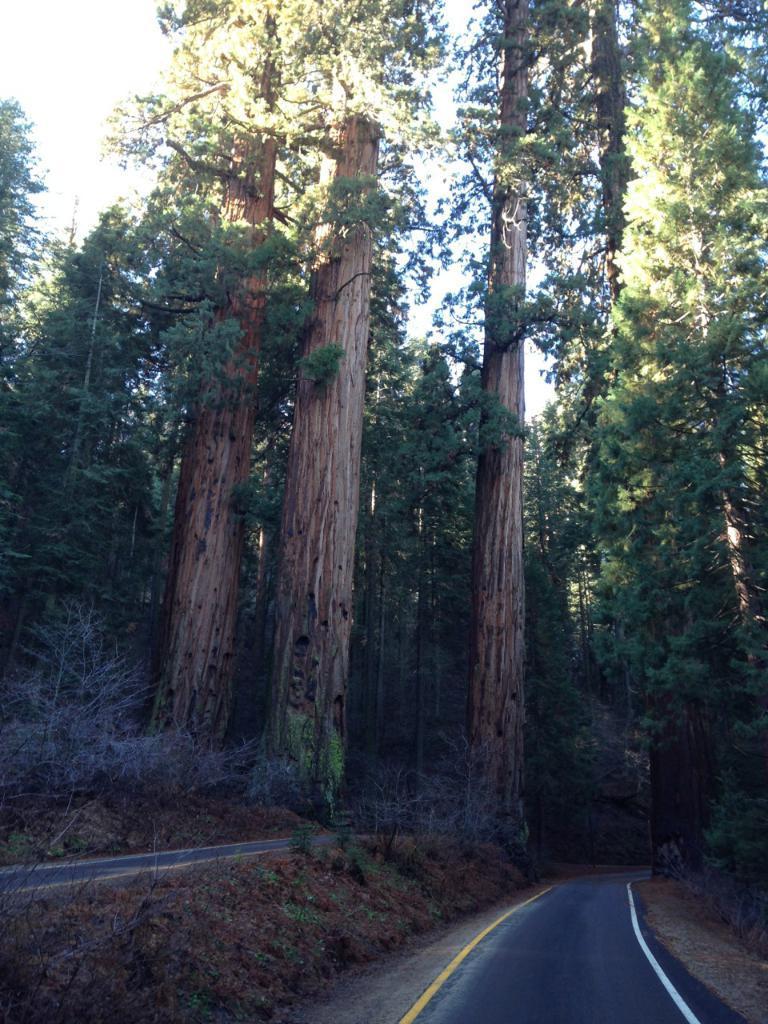In one or two sentences, can you explain what this image depicts? In this picture, we can see trees, roads, ground with some plants and the sky. 